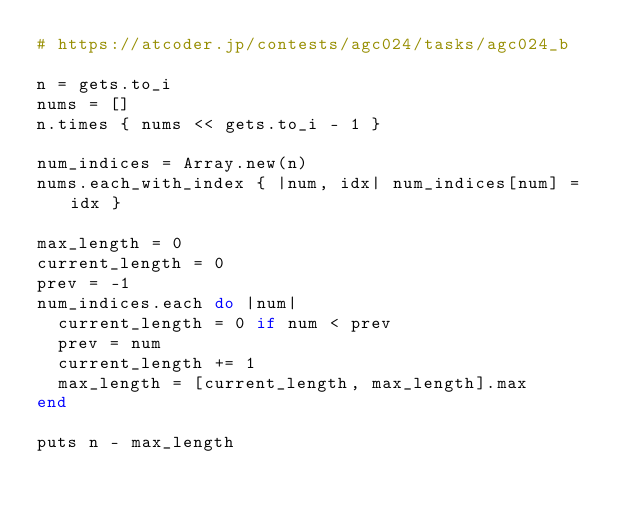Convert code to text. <code><loc_0><loc_0><loc_500><loc_500><_Ruby_># https://atcoder.jp/contests/agc024/tasks/agc024_b

n = gets.to_i
nums = []
n.times { nums << gets.to_i - 1 }

num_indices = Array.new(n)
nums.each_with_index { |num, idx| num_indices[num] = idx }

max_length = 0
current_length = 0
prev = -1
num_indices.each do |num|
  current_length = 0 if num < prev
  prev = num
  current_length += 1
  max_length = [current_length, max_length].max
end

puts n - max_length</code> 